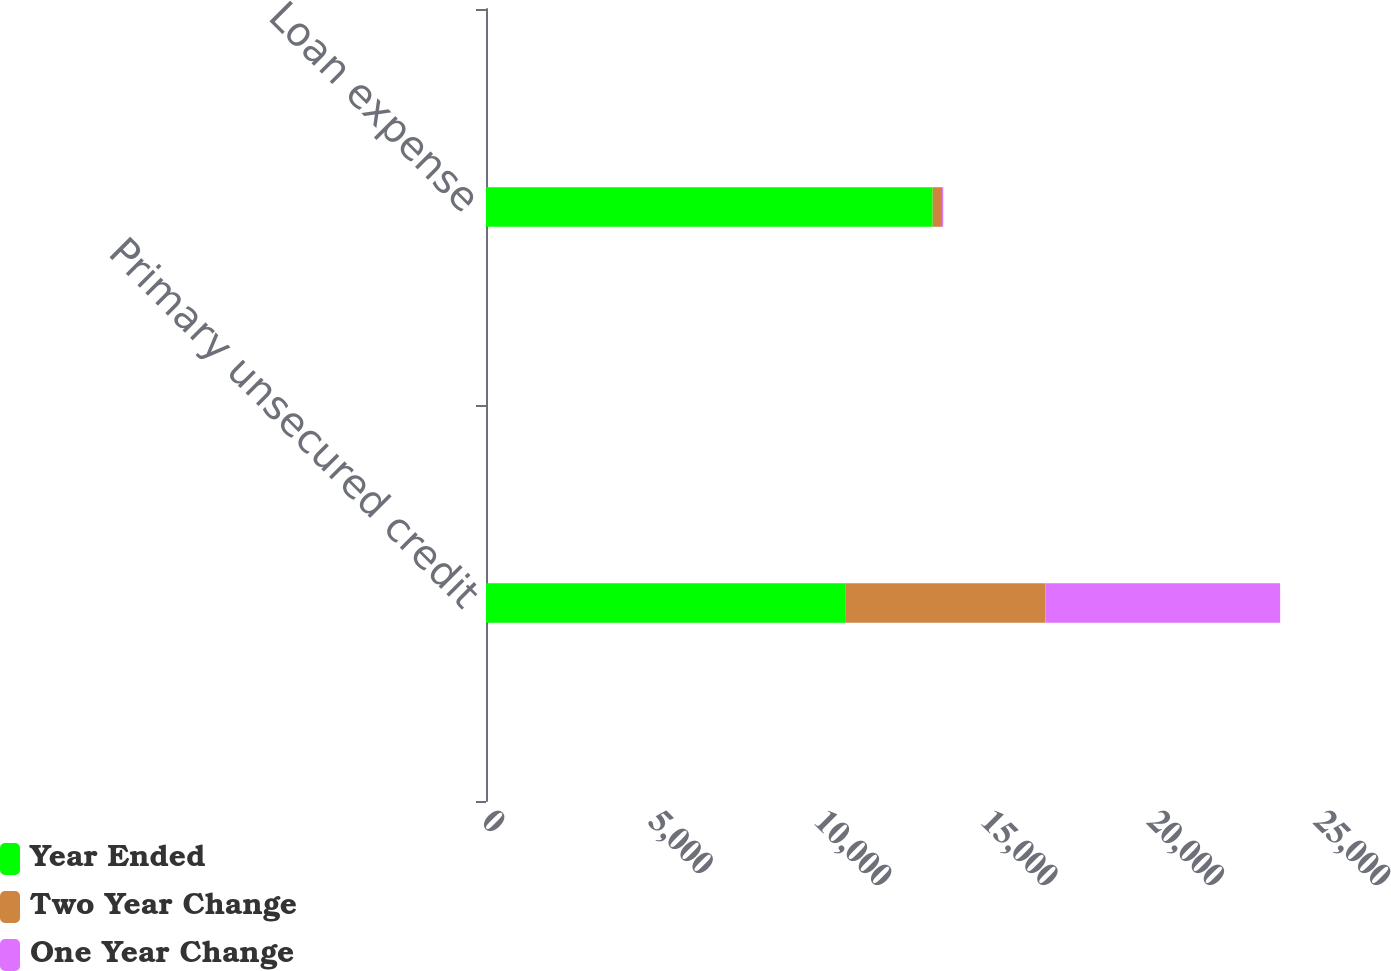Convert chart to OTSL. <chart><loc_0><loc_0><loc_500><loc_500><stacked_bar_chart><ecel><fcel>Primary unsecured credit<fcel>Loan expense<nl><fcel>Year Ended<fcel>10812<fcel>13421<nl><fcel>Two Year Change<fcel>5999<fcel>282<nl><fcel>One Year Change<fcel>7051<fcel>36<nl></chart> 